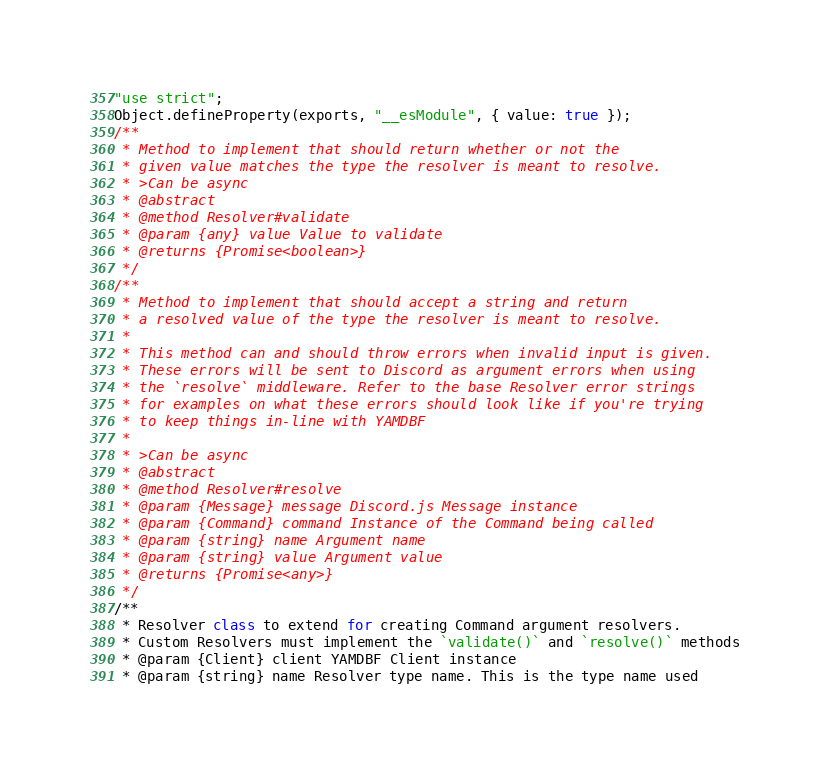Convert code to text. <code><loc_0><loc_0><loc_500><loc_500><_JavaScript_>"use strict";
Object.defineProperty(exports, "__esModule", { value: true });
/**
 * Method to implement that should return whether or not the
 * given value matches the type the resolver is meant to resolve.
 * >Can be async
 * @abstract
 * @method Resolver#validate
 * @param {any} value Value to validate
 * @returns {Promise<boolean>}
 */
/**
 * Method to implement that should accept a string and return
 * a resolved value of the type the resolver is meant to resolve.
 *
 * This method can and should throw errors when invalid input is given.
 * These errors will be sent to Discord as argument errors when using
 * the `resolve` middleware. Refer to the base Resolver error strings
 * for examples on what these errors should look like if you're trying
 * to keep things in-line with YAMDBF
 *
 * >Can be async
 * @abstract
 * @method Resolver#resolve
 * @param {Message} message Discord.js Message instance
 * @param {Command} command Instance of the Command being called
 * @param {string} name Argument name
 * @param {string} value Argument value
 * @returns {Promise<any>}
 */
/**
 * Resolver class to extend for creating Command argument resolvers.
 * Custom Resolvers must implement the `validate()` and `resolve()` methods
 * @param {Client} client YAMDBF Client instance
 * @param {string} name Resolver type name. This is the type name used</code> 